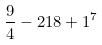<formula> <loc_0><loc_0><loc_500><loc_500>\frac { 9 } { 4 } - 2 1 8 + 1 ^ { 7 }</formula> 